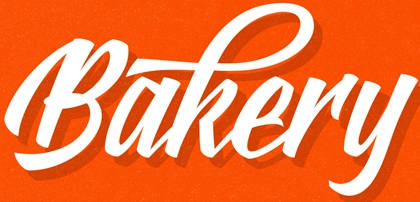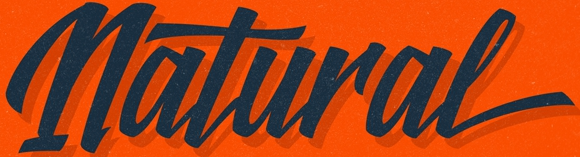Read the text from these images in sequence, separated by a semicolon. Bakery; Natural 